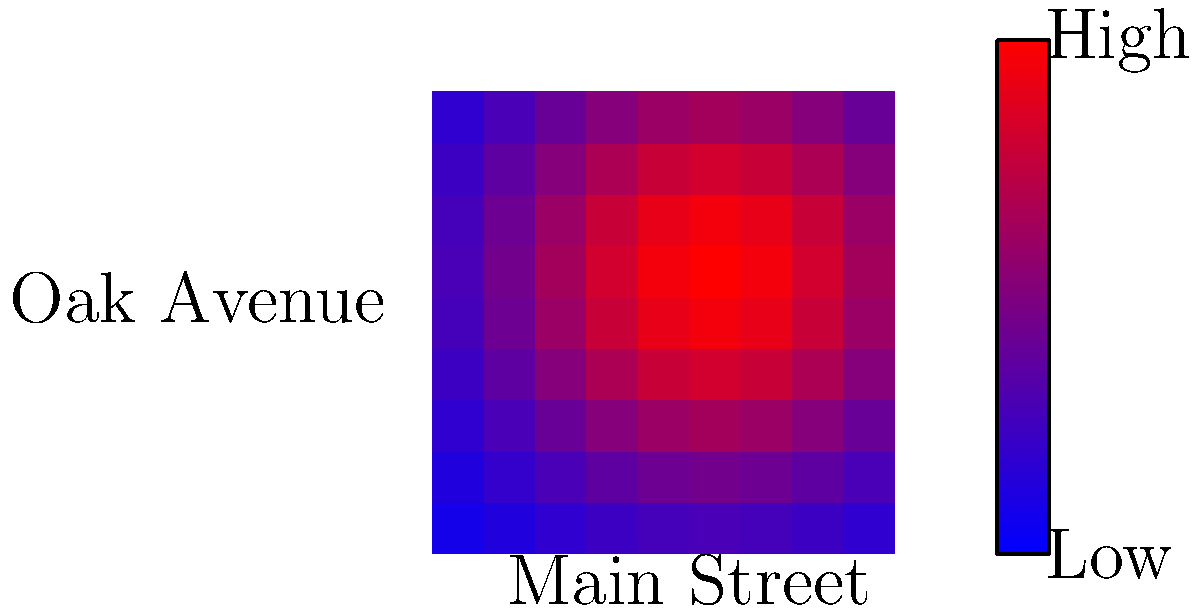Based on the heatmap of foot traffic patterns in a local business district, which area would you recommend for a new family-owned business to maximize customer exposure, and why? To answer this question, we need to analyze the heatmap and understand its implications for foot traffic patterns:

1. The heatmap represents foot traffic intensity, with red indicating high traffic and blue indicating low traffic.

2. The x-axis represents Main Street, while the y-axis represents Oak Avenue.

3. The center of the heatmap (coordinates approximately (5,5)) shows the highest foot traffic, indicated by the intense red color.

4. This high-traffic area is likely the intersection of Main Street and Oak Avenue.

5. The foot traffic gradually decreases as we move away from the center, transitioning from red to blue.

6. The corners of the map show the lowest foot traffic, represented by dark blue colors.

7. For a new family-owned business, maximizing customer exposure would involve choosing a location with high foot traffic.

8. The ideal location would be as close as possible to the center of the heatmap, where Main Street and Oak Avenue intersect.

9. This central location would provide the highest potential for customer interactions and visibility for the new business.

10. Additionally, being at the intersection of two main streets could offer better accessibility for customers coming from different directions.

Therefore, the best recommendation for a new family-owned business would be to locate as close as possible to the intersection of Main Street and Oak Avenue, where foot traffic is highest.
Answer: Near the intersection of Main Street and Oak Avenue 